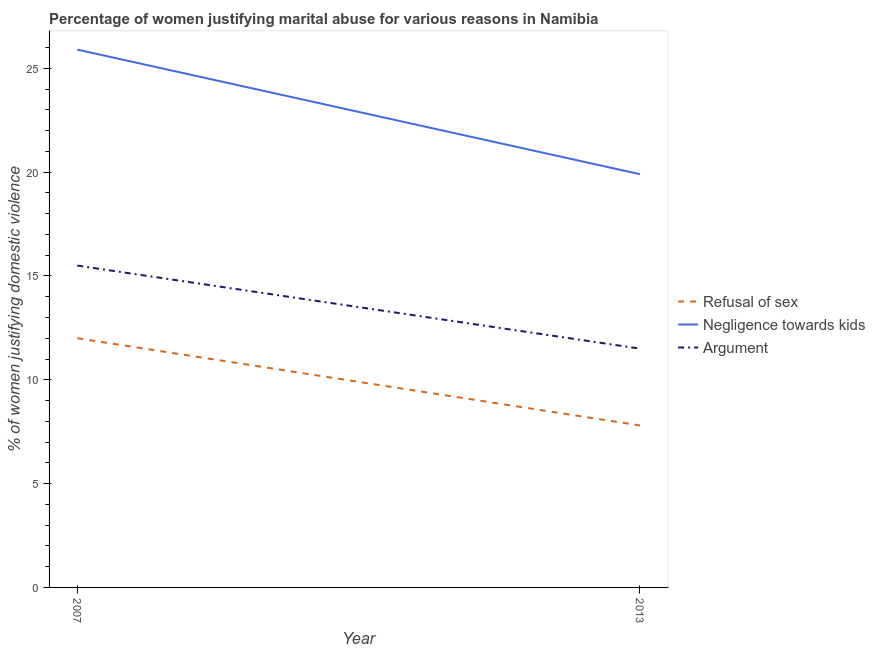Does the line corresponding to percentage of women justifying domestic violence due to arguments intersect with the line corresponding to percentage of women justifying domestic violence due to negligence towards kids?
Your answer should be very brief. No. Is the number of lines equal to the number of legend labels?
Offer a very short reply. Yes. What is the total percentage of women justifying domestic violence due to negligence towards kids in the graph?
Keep it short and to the point. 45.8. What is the average percentage of women justifying domestic violence due to arguments per year?
Offer a very short reply. 13.5. In the year 2013, what is the difference between the percentage of women justifying domestic violence due to negligence towards kids and percentage of women justifying domestic violence due to arguments?
Your answer should be very brief. 8.4. In how many years, is the percentage of women justifying domestic violence due to arguments greater than 12 %?
Your answer should be compact. 1. What is the ratio of the percentage of women justifying domestic violence due to negligence towards kids in 2007 to that in 2013?
Give a very brief answer. 1.3. Is the percentage of women justifying domestic violence due to negligence towards kids in 2007 less than that in 2013?
Keep it short and to the point. No. In how many years, is the percentage of women justifying domestic violence due to refusal of sex greater than the average percentage of women justifying domestic violence due to refusal of sex taken over all years?
Give a very brief answer. 1. Is it the case that in every year, the sum of the percentage of women justifying domestic violence due to refusal of sex and percentage of women justifying domestic violence due to negligence towards kids is greater than the percentage of women justifying domestic violence due to arguments?
Your answer should be compact. Yes. Is the percentage of women justifying domestic violence due to arguments strictly less than the percentage of women justifying domestic violence due to negligence towards kids over the years?
Offer a terse response. Yes. How many years are there in the graph?
Your response must be concise. 2. What is the difference between two consecutive major ticks on the Y-axis?
Offer a terse response. 5. Are the values on the major ticks of Y-axis written in scientific E-notation?
Keep it short and to the point. No. Does the graph contain any zero values?
Offer a terse response. No. Where does the legend appear in the graph?
Make the answer very short. Center right. How many legend labels are there?
Offer a terse response. 3. What is the title of the graph?
Give a very brief answer. Percentage of women justifying marital abuse for various reasons in Namibia. What is the label or title of the Y-axis?
Keep it short and to the point. % of women justifying domestic violence. What is the % of women justifying domestic violence of Negligence towards kids in 2007?
Offer a terse response. 25.9. What is the % of women justifying domestic violence in Refusal of sex in 2013?
Keep it short and to the point. 7.8. Across all years, what is the maximum % of women justifying domestic violence in Refusal of sex?
Your response must be concise. 12. Across all years, what is the maximum % of women justifying domestic violence of Negligence towards kids?
Provide a succinct answer. 25.9. Across all years, what is the maximum % of women justifying domestic violence of Argument?
Ensure brevity in your answer.  15.5. What is the total % of women justifying domestic violence in Refusal of sex in the graph?
Offer a very short reply. 19.8. What is the total % of women justifying domestic violence of Negligence towards kids in the graph?
Give a very brief answer. 45.8. What is the difference between the % of women justifying domestic violence of Refusal of sex in 2007 and that in 2013?
Offer a terse response. 4.2. What is the difference between the % of women justifying domestic violence of Negligence towards kids in 2007 and that in 2013?
Keep it short and to the point. 6. What is the difference between the % of women justifying domestic violence of Refusal of sex in 2007 and the % of women justifying domestic violence of Negligence towards kids in 2013?
Offer a very short reply. -7.9. What is the difference between the % of women justifying domestic violence in Negligence towards kids in 2007 and the % of women justifying domestic violence in Argument in 2013?
Provide a succinct answer. 14.4. What is the average % of women justifying domestic violence of Refusal of sex per year?
Your response must be concise. 9.9. What is the average % of women justifying domestic violence of Negligence towards kids per year?
Give a very brief answer. 22.9. What is the average % of women justifying domestic violence of Argument per year?
Ensure brevity in your answer.  13.5. In the year 2013, what is the difference between the % of women justifying domestic violence of Refusal of sex and % of women justifying domestic violence of Negligence towards kids?
Keep it short and to the point. -12.1. What is the ratio of the % of women justifying domestic violence in Refusal of sex in 2007 to that in 2013?
Make the answer very short. 1.54. What is the ratio of the % of women justifying domestic violence in Negligence towards kids in 2007 to that in 2013?
Offer a terse response. 1.3. What is the ratio of the % of women justifying domestic violence of Argument in 2007 to that in 2013?
Make the answer very short. 1.35. What is the difference between the highest and the second highest % of women justifying domestic violence in Negligence towards kids?
Offer a very short reply. 6. What is the difference between the highest and the lowest % of women justifying domestic violence in Refusal of sex?
Offer a terse response. 4.2. What is the difference between the highest and the lowest % of women justifying domestic violence of Argument?
Your answer should be compact. 4. 